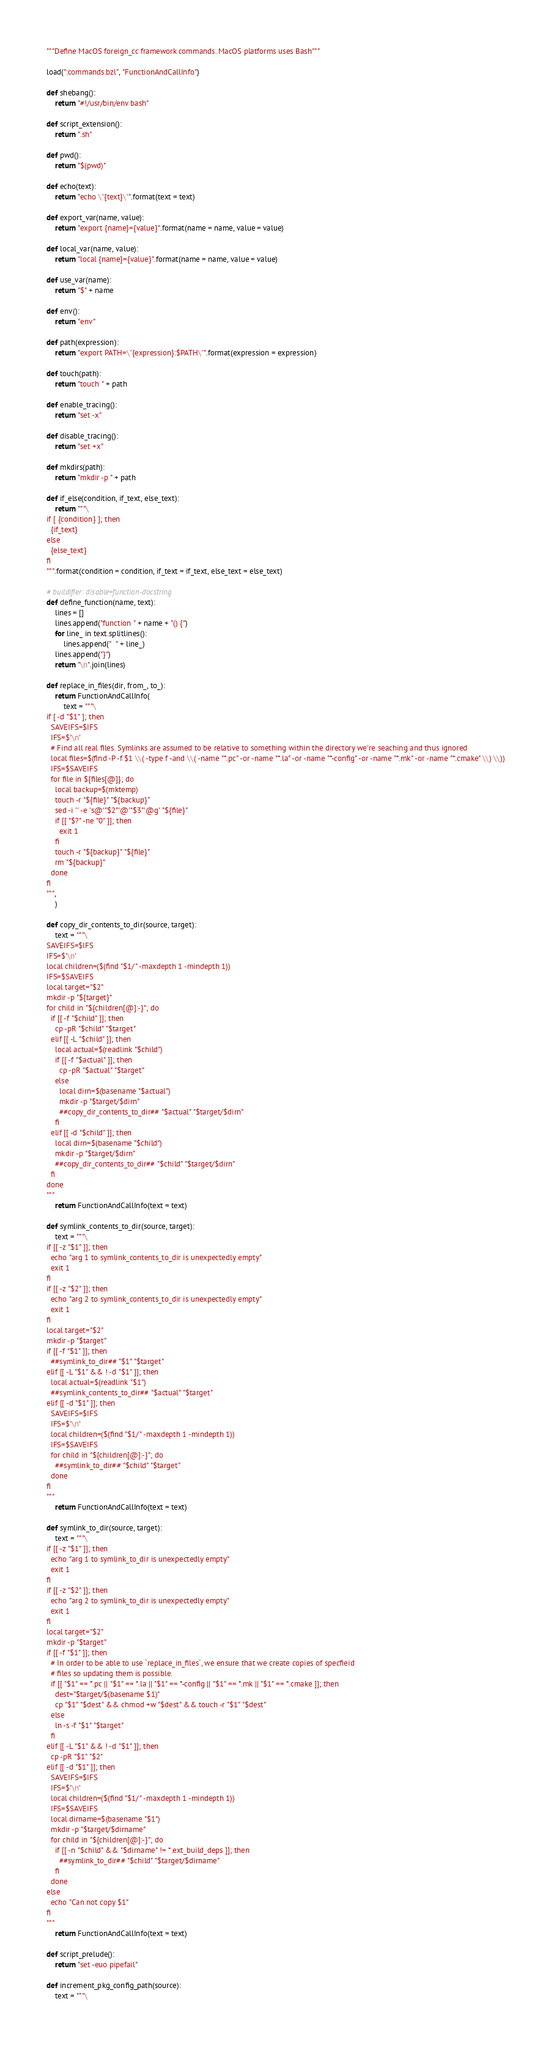<code> <loc_0><loc_0><loc_500><loc_500><_Python_>"""Define MacOS foreign_cc framework commands. MacOS platforms uses Bash"""

load(":commands.bzl", "FunctionAndCallInfo")

def shebang():
    return "#!/usr/bin/env bash"

def script_extension():
    return ".sh"

def pwd():
    return "$(pwd)"

def echo(text):
    return "echo \"{text}\"".format(text = text)

def export_var(name, value):
    return "export {name}={value}".format(name = name, value = value)

def local_var(name, value):
    return "local {name}={value}".format(name = name, value = value)

def use_var(name):
    return "$" + name

def env():
    return "env"

def path(expression):
    return "export PATH=\"{expression}:$PATH\"".format(expression = expression)

def touch(path):
    return "touch " + path

def enable_tracing():
    return "set -x"

def disable_tracing():
    return "set +x"

def mkdirs(path):
    return "mkdir -p " + path

def if_else(condition, if_text, else_text):
    return """\
if [ {condition} ]; then
  {if_text}
else
  {else_text}
fi
""".format(condition = condition, if_text = if_text, else_text = else_text)

# buildifier: disable=function-docstring
def define_function(name, text):
    lines = []
    lines.append("function " + name + "() {")
    for line_ in text.splitlines():
        lines.append("  " + line_)
    lines.append("}")
    return "\n".join(lines)

def replace_in_files(dir, from_, to_):
    return FunctionAndCallInfo(
        text = """\
if [ -d "$1" ]; then
  SAVEIFS=$IFS
  IFS=$'\n'
  # Find all real files. Symlinks are assumed to be relative to something within the directory we're seaching and thus ignored
  local files=$(find -P -f $1 \\( -type f -and \\( -name "*.pc" -or -name "*.la" -or -name "*-config" -or -name "*.mk" -or -name "*.cmake" \\) \\))
  IFS=$SAVEIFS
  for file in ${files[@]}; do
    local backup=$(mktemp)
    touch -r "${file}" "${backup}"
    sed -i '' -e 's@'"$2"'@'"$3"'@g' "${file}"
    if [[ "$?" -ne "0" ]]; then
      exit 1
    fi
    touch -r "${backup}" "${file}"
    rm "${backup}"
  done
fi
""",
    )

def copy_dir_contents_to_dir(source, target):
    text = """\
SAVEIFS=$IFS
IFS=$'\n'
local children=($(find "$1/" -maxdepth 1 -mindepth 1))
IFS=$SAVEIFS
local target="$2"
mkdir -p "${target}"
for child in "${children[@]:-}"; do
  if [[ -f "$child" ]]; then
    cp -pR "$child" "$target"
  elif [[ -L "$child" ]]; then
    local actual=$(readlink "$child")
    if [[ -f "$actual" ]]; then
      cp -pR "$actual" "$target"
    else
      local dirn=$(basename "$actual")
      mkdir -p "$target/$dirn"
      ##copy_dir_contents_to_dir## "$actual" "$target/$dirn"
    fi
  elif [[ -d "$child" ]]; then
    local dirn=$(basename "$child")
    mkdir -p "$target/$dirn"
    ##copy_dir_contents_to_dir## "$child" "$target/$dirn"
  fi
done
"""
    return FunctionAndCallInfo(text = text)

def symlink_contents_to_dir(source, target):
    text = """\
if [[ -z "$1" ]]; then
  echo "arg 1 to symlink_contents_to_dir is unexpectedly empty"
  exit 1
fi
if [[ -z "$2" ]]; then
  echo "arg 2 to symlink_contents_to_dir is unexpectedly empty"
  exit 1
fi
local target="$2"
mkdir -p "$target"
if [[ -f "$1" ]]; then
  ##symlink_to_dir## "$1" "$target"
elif [[ -L "$1" && ! -d "$1" ]]; then
  local actual=$(readlink "$1")
  ##symlink_contents_to_dir## "$actual" "$target"
elif [[ -d "$1" ]]; then
  SAVEIFS=$IFS
  IFS=$'\n'
  local children=($(find "$1/" -maxdepth 1 -mindepth 1))
  IFS=$SAVEIFS
  for child in "${children[@]:-}"; do
    ##symlink_to_dir## "$child" "$target"
  done
fi
"""
    return FunctionAndCallInfo(text = text)

def symlink_to_dir(source, target):
    text = """\
if [[ -z "$1" ]]; then
  echo "arg 1 to symlink_to_dir is unexpectedly empty"
  exit 1
fi
if [[ -z "$2" ]]; then
  echo "arg 2 to symlink_to_dir is unexpectedly empty"
  exit 1
fi
local target="$2"
mkdir -p "$target"
if [[ -f "$1" ]]; then
  # In order to be able to use `replace_in_files`, we ensure that we create copies of specfieid
  # files so updating them is possible.
  if [[ "$1" == *.pc || "$1" == *.la || "$1" == *-config || "$1" == *.mk || "$1" == *.cmake ]]; then
    dest="$target/$(basename $1)"
    cp "$1" "$dest" && chmod +w "$dest" && touch -r "$1" "$dest"
  else
    ln -s -f "$1" "$target"
  fi
elif [[ -L "$1" && ! -d "$1" ]]; then
  cp -pR "$1" "$2"
elif [[ -d "$1" ]]; then
  SAVEIFS=$IFS
  IFS=$'\n'
  local children=($(find "$1/" -maxdepth 1 -mindepth 1))
  IFS=$SAVEIFS
  local dirname=$(basename "$1")
  mkdir -p "$target/$dirname"
  for child in "${children[@]:-}"; do
    if [[ -n "$child" && "$dirname" != *.ext_build_deps ]]; then
      ##symlink_to_dir## "$child" "$target/$dirname"
    fi
  done
else
  echo "Can not copy $1"
fi
"""
    return FunctionAndCallInfo(text = text)

def script_prelude():
    return "set -euo pipefail"

def increment_pkg_config_path(source):
    text = """\</code> 